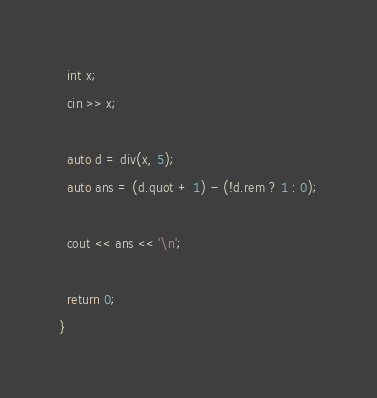Convert code to text. <code><loc_0><loc_0><loc_500><loc_500><_C++_>  int x;
  cin >> x;

  auto d = div(x, 5);
  auto ans = (d.quot + 1) - (!d.rem ? 1 : 0);

  cout << ans << '\n';

  return 0;
}
</code> 